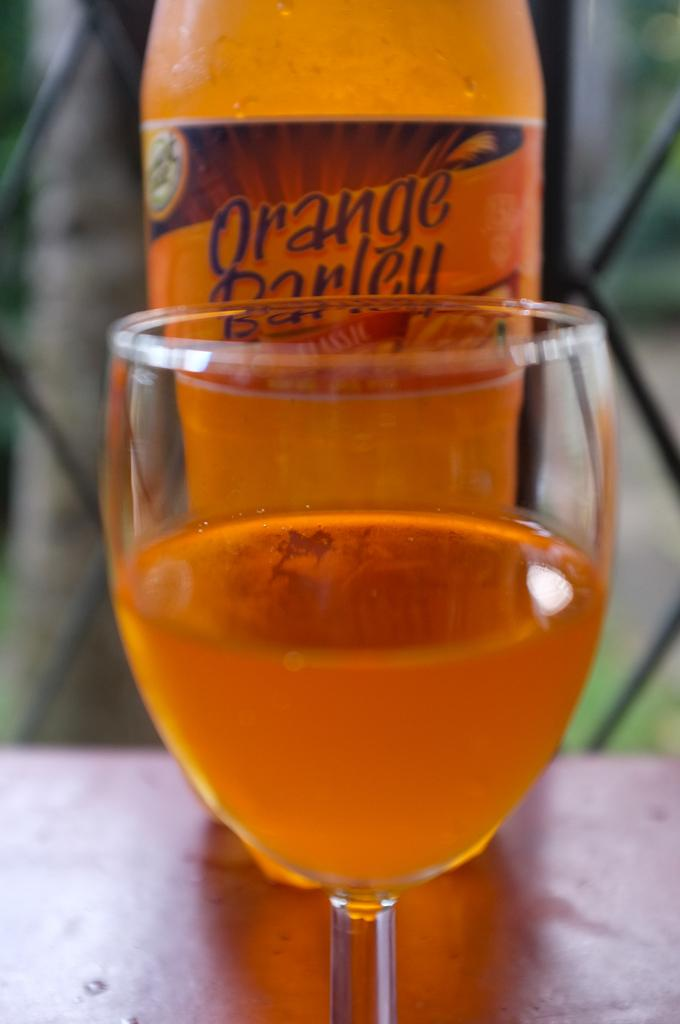What is in the glass that is visible in the image? There is a glass of orange juice in the image. Can you see any other items related to orange juice in the image? Yes, there is an orange juice bottle in the background of the image. What type of brass instrument can be seen in the image? There is no brass instrument present in the image; it features a glass of orange juice and an orange juice bottle. 